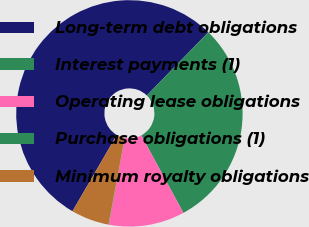<chart> <loc_0><loc_0><loc_500><loc_500><pie_chart><fcel>Long-term debt obligations<fcel>Interest payments (1)<fcel>Operating lease obligations<fcel>Purchase obligations (1)<fcel>Minimum royalty obligations<nl><fcel>53.89%<fcel>29.81%<fcel>10.82%<fcel>0.05%<fcel>5.43%<nl></chart> 